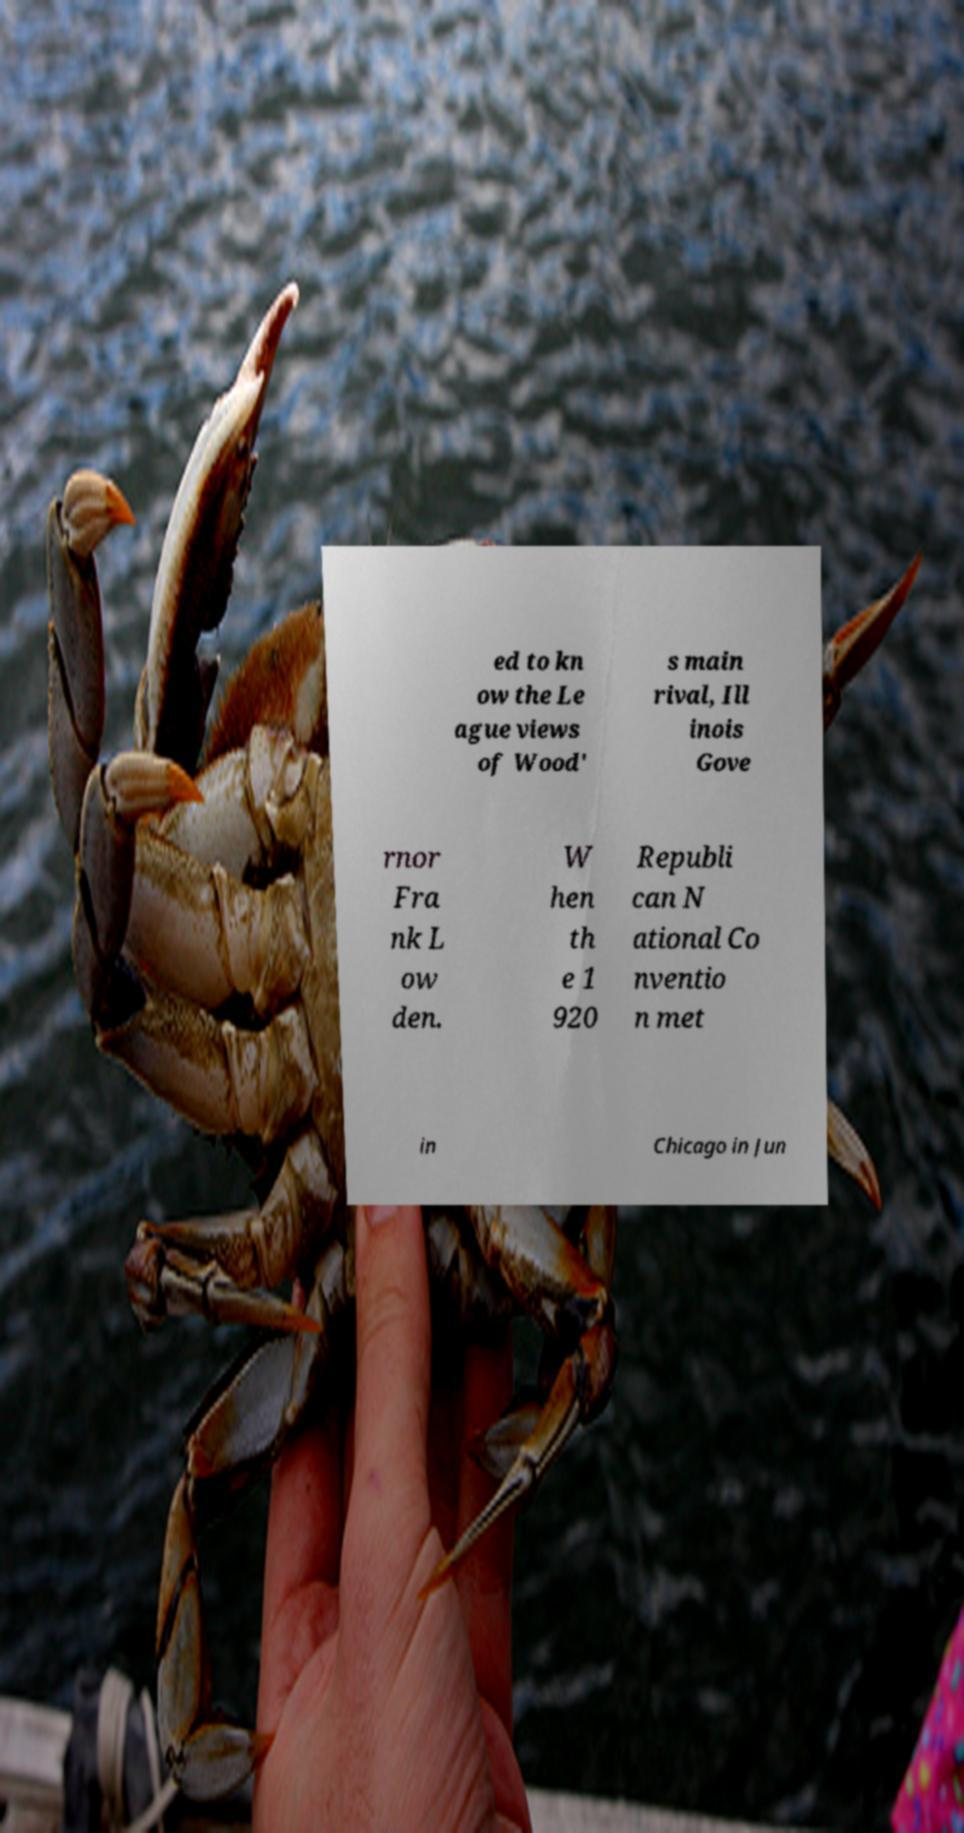I need the written content from this picture converted into text. Can you do that? ed to kn ow the Le ague views of Wood' s main rival, Ill inois Gove rnor Fra nk L ow den. W hen th e 1 920 Republi can N ational Co nventio n met in Chicago in Jun 